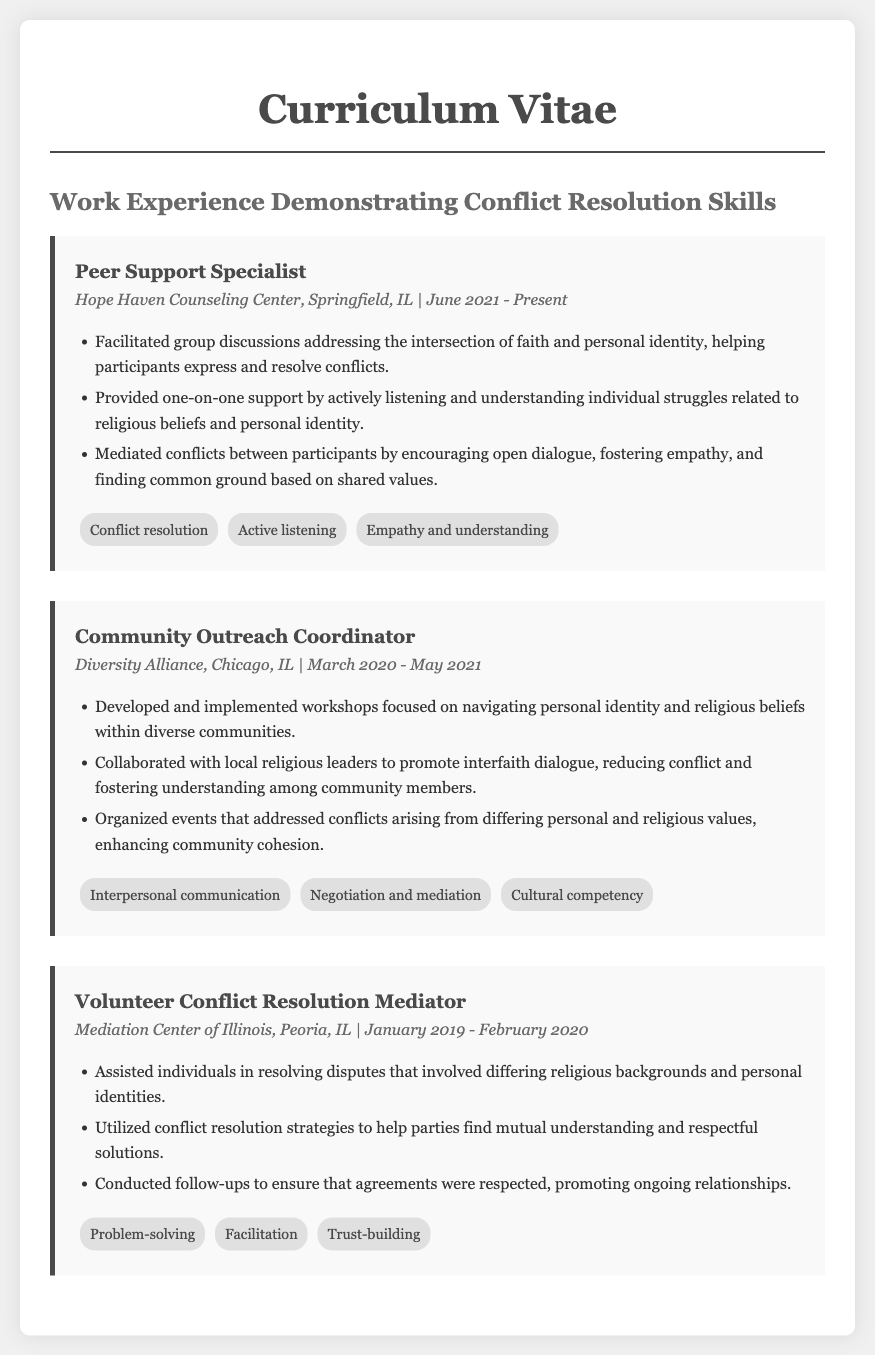What is the job title for the position held at Hope Haven Counseling Center? The job title for the position mentioned in the document is the first item listed under that job.
Answer: Peer Support Specialist When did the Community Outreach Coordinator position start? The start date for the Community Outreach Coordinator's position is provided in the job details section.
Answer: March 2020 What skill is associated with the job of Peer Support Specialist? The skills listed are derived from the job description, and one of them directly relates to resolving conflicts.
Answer: Conflict resolution Who collaborated with the Community Outreach Coordinator? The document specifies a group that interacted with the Community Outreach Coordinator for promoting interfaith dialogue.
Answer: Local religious leaders In what capacity did the individual work at the Mediation Center of Illinois? This information can be found in the job title section for that experience.
Answer: Volunteer Conflict Resolution Mediator What main activity was emphasized in the role of Volunteer Conflict Resolution Mediator? The document highlights a specific activity associated with the mediating role in resolving disputes.
Answer: Resolving disputes Which organization was associated with the job held from June 2021 to Present? The organization name is part of the job details section related to the current job title.
Answer: Hope Haven Counseling Center What was a focus of the workshops developed by the Community Outreach Coordinator? The document mentions the content of the workshops being developed and implemented.
Answer: Navigating personal identity and religious beliefs How long did the individual serve as a Peer Support Specialist? The duration of service is inferred from the job title and details of that position.
Answer: Since June 2021 to Present 